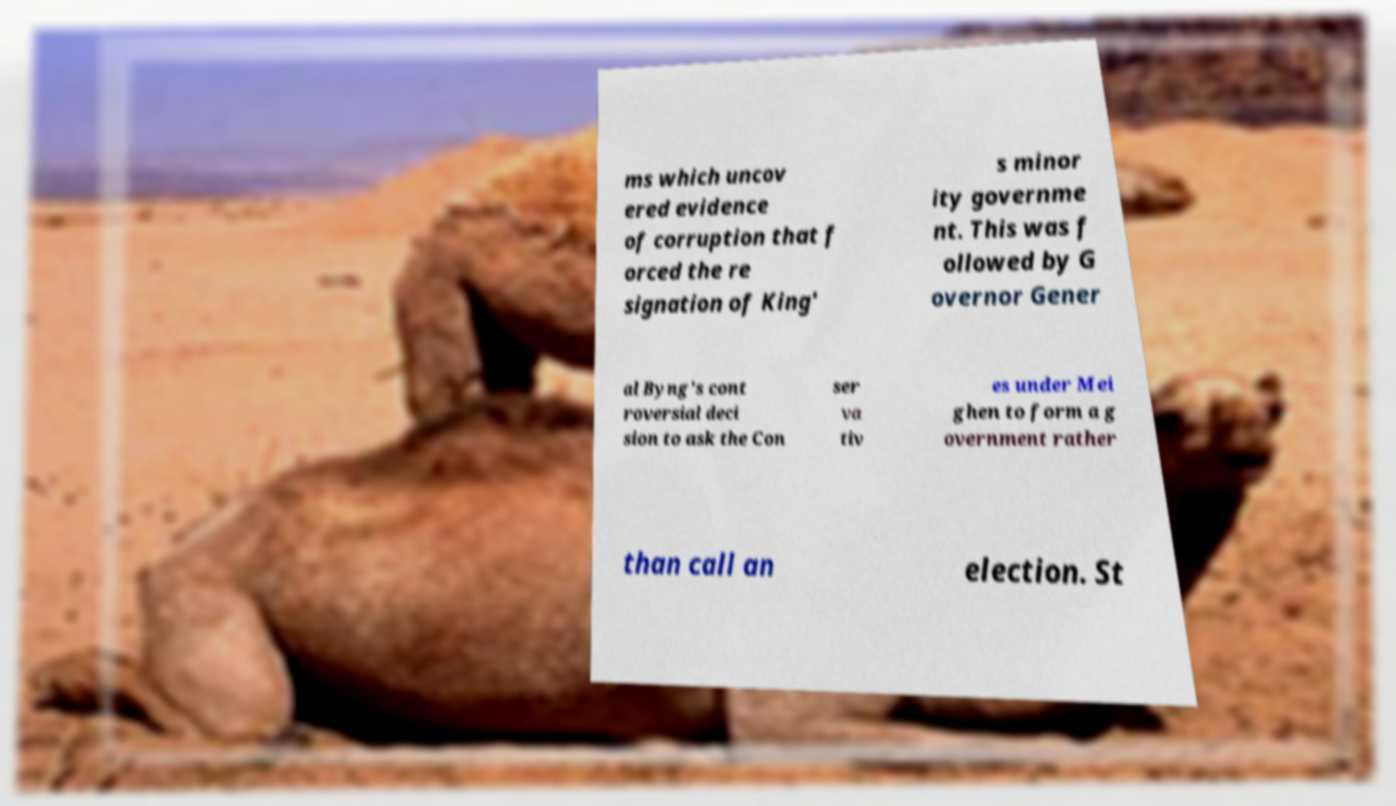Please read and relay the text visible in this image. What does it say? ms which uncov ered evidence of corruption that f orced the re signation of King' s minor ity governme nt. This was f ollowed by G overnor Gener al Byng's cont roversial deci sion to ask the Con ser va tiv es under Mei ghen to form a g overnment rather than call an election. St 